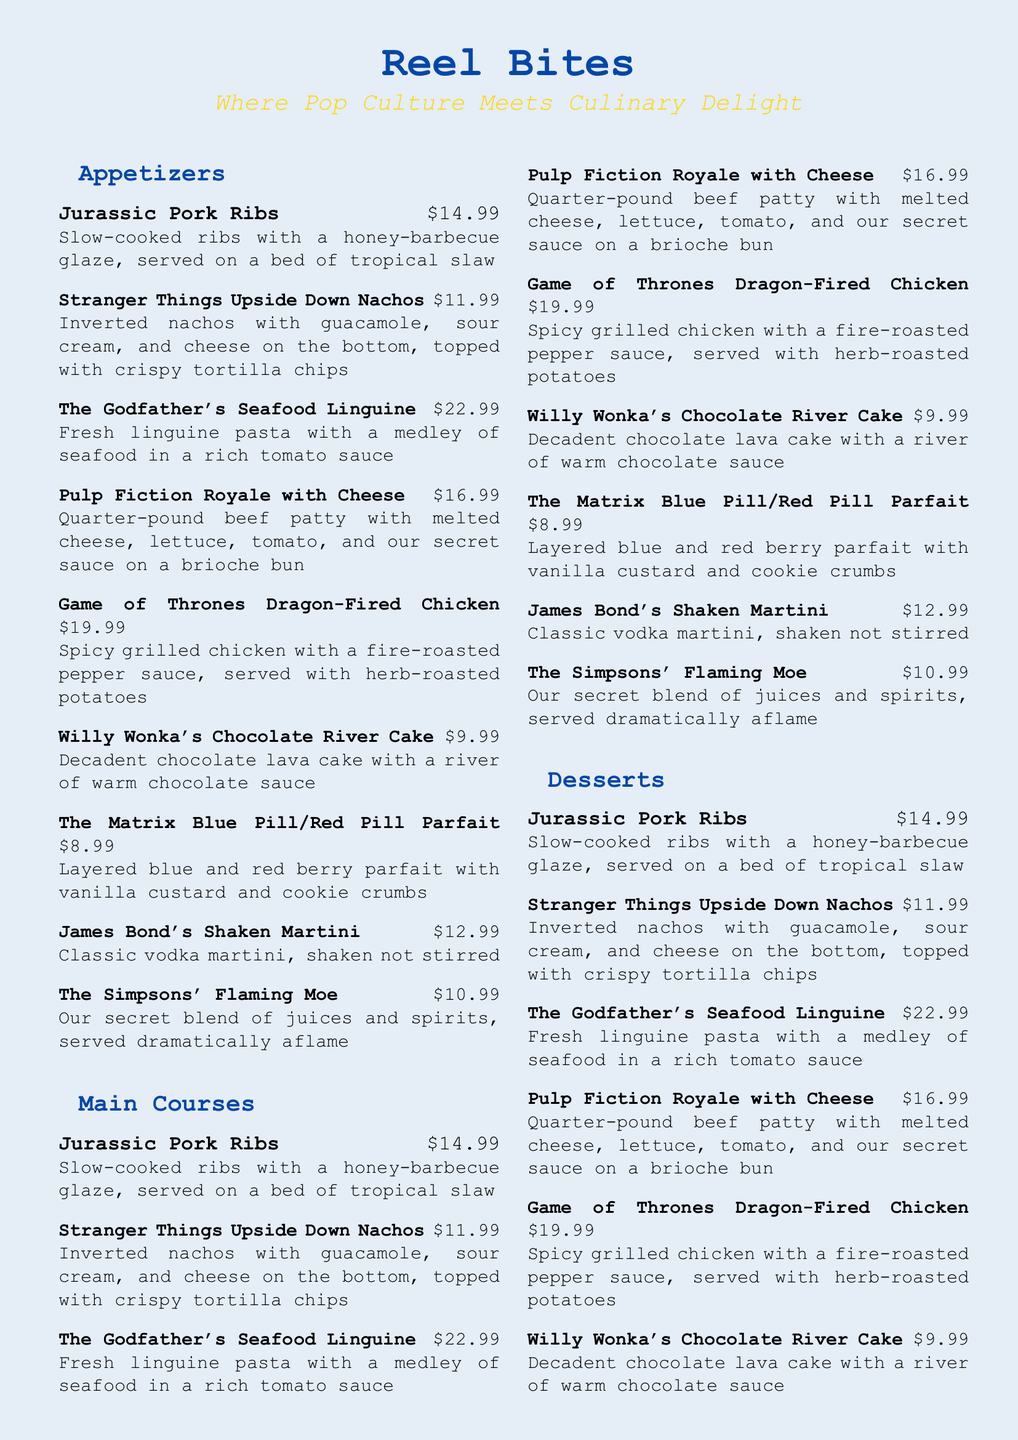What is the name of the restaurant? The name of the restaurant is prominently featured at the top of the menu.
Answer: Reel Bites What is the price of the Game of Thrones Dragon-Fired Chicken? The price is listed next to the dish on the menu.
Answer: $19.99 Which dessert is inspired by Willy Wonka? The dessert inspired by Willy Wonka is specifically named in the dessert section.
Answer: Willy Wonka's Chocolate River Cake How much do the Stranger Things Upside Down Nachos cost? The cost is clearly stated next to the dish on the menu.
Answer: $11.99 What beverage is served "shaken not stirred"? The beverage is explicitly named in the drinks section of the menu.
Answer: James Bond's Shaken Martini What appetizer features slow-cooked ribs? The appetizer is mentioned in the appetizers section with its description.
Answer: Jurassic Pork Ribs How many total sections are there in the menu? The sections are listed at the beginning of the multicols section.
Answer: Four What type of pasta is used in The Godfather's Seafood Linguine? The type of pasta is described in the item details.
Answer: Linguine Which dish features an inverted serving style? The dish's serving style is highlighted in its description on the menu.
Answer: Stranger Things Upside Down Nachos 